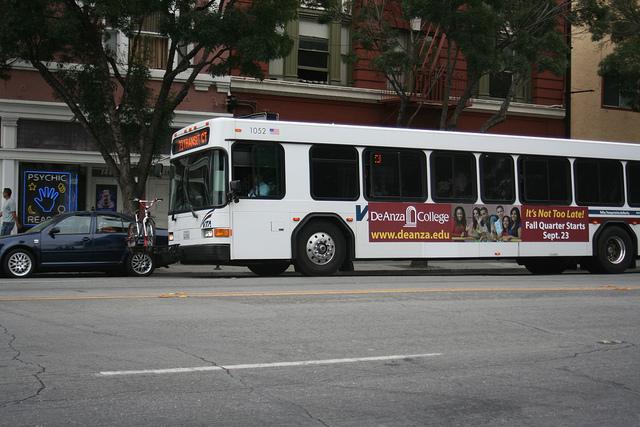What does the blue sign say?
Quick response, please. Psychic. What color is the bus?
Quick response, please. White. Are the rims on the bus gold?
Quick response, please. No. What is that a picture of in front of the bus and close to the car?
Answer briefly. Hand. What institute of higher learning is being advertised on the side of the bus?
Answer briefly. De anza college. Where does this bus go?
Give a very brief answer. Downtown. 